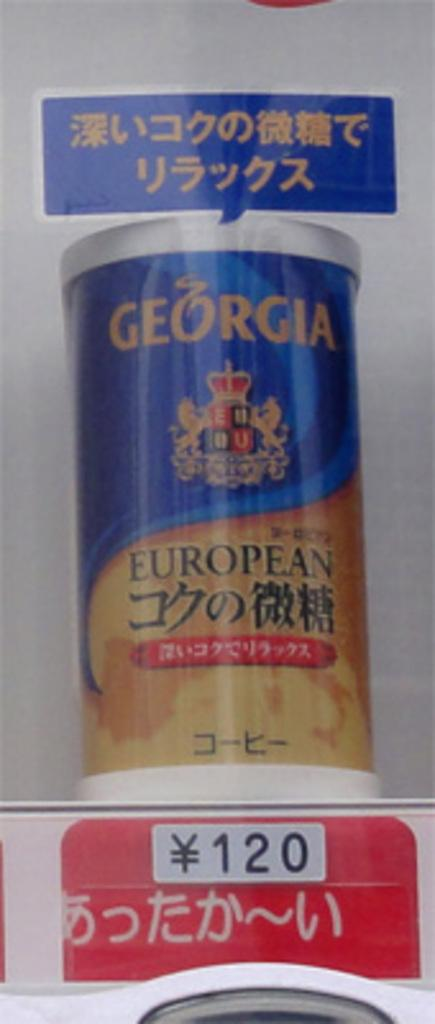<image>
Present a compact description of the photo's key features. A container with the brand Georgia European in blue and yellow with a price of 120 yen. 